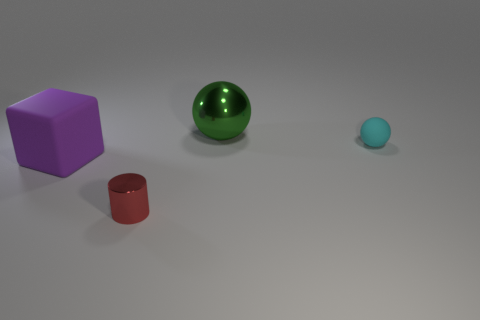Subtract 1 spheres. How many spheres are left? 1 Subtract all cyan cubes. How many cyan spheres are left? 1 Add 1 large purple rubber blocks. How many large purple rubber blocks are left? 2 Add 3 big green matte cylinders. How many big green matte cylinders exist? 3 Add 2 big matte objects. How many objects exist? 6 Subtract 0 purple cylinders. How many objects are left? 4 Subtract all red spheres. Subtract all blue blocks. How many spheres are left? 2 Subtract all large brown matte objects. Subtract all red cylinders. How many objects are left? 3 